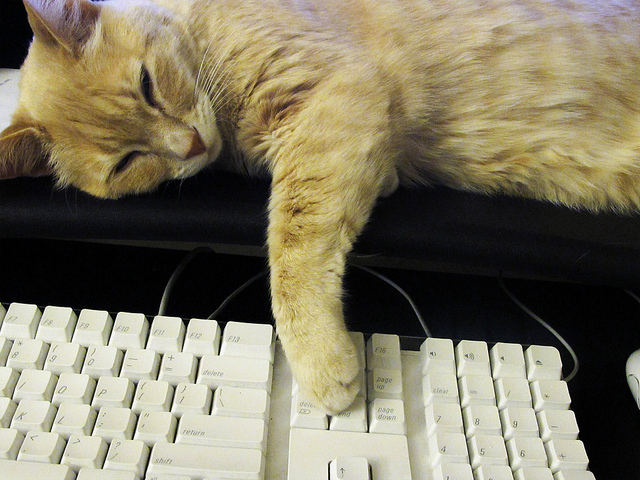Read all the text in this image. / P 4 8 